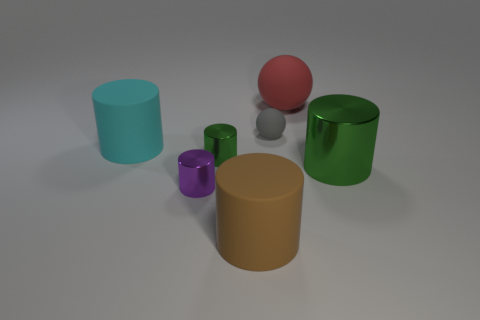Subtract 2 cylinders. How many cylinders are left? 3 Subtract all purple cylinders. How many cylinders are left? 4 Subtract all yellow cylinders. Subtract all red balls. How many cylinders are left? 5 Add 1 small cylinders. How many objects exist? 8 Subtract all cylinders. How many objects are left? 2 Subtract all purple cubes. Subtract all tiny cylinders. How many objects are left? 5 Add 6 tiny green metallic things. How many tiny green metallic things are left? 7 Add 3 large red spheres. How many large red spheres exist? 4 Subtract 0 purple cubes. How many objects are left? 7 